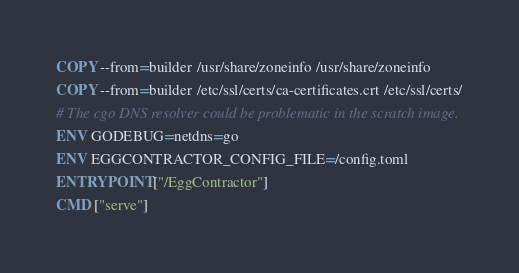Convert code to text. <code><loc_0><loc_0><loc_500><loc_500><_Dockerfile_>COPY --from=builder /usr/share/zoneinfo /usr/share/zoneinfo
COPY --from=builder /etc/ssl/certs/ca-certificates.crt /etc/ssl/certs/
# The cgo DNS resolver could be problematic in the scratch image.
ENV GODEBUG=netdns=go
ENV EGGCONTRACTOR_CONFIG_FILE=/config.toml
ENTRYPOINT ["/EggContractor"]
CMD ["serve"]
</code> 